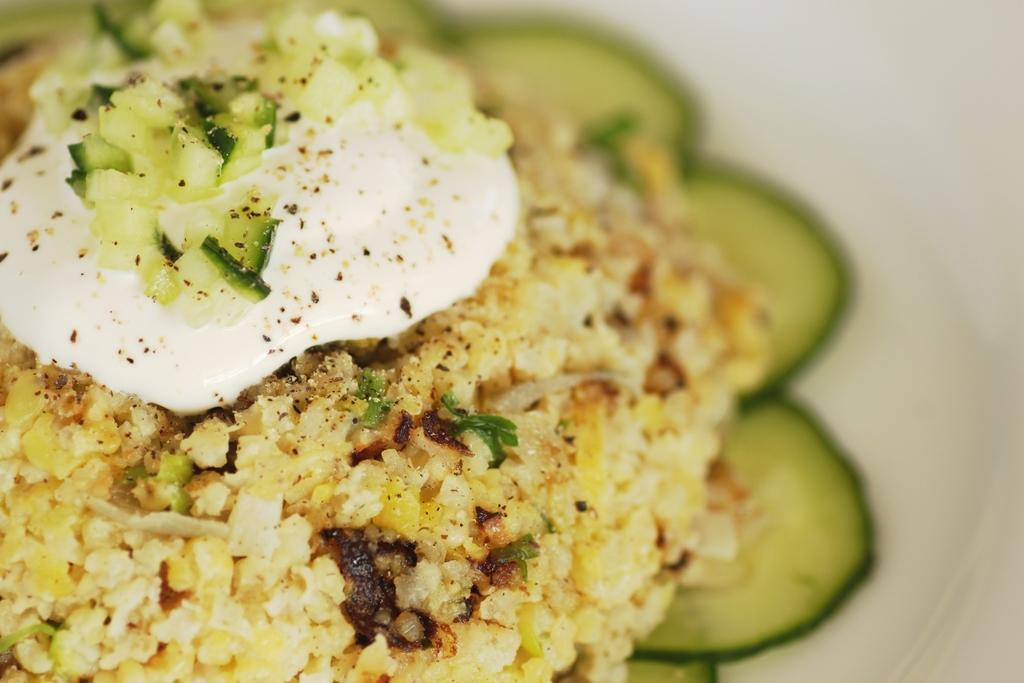What is placed on the plate in the image? There is a plate with food items on it in the image. Can you describe the food items on the plate? Unfortunately, the specific food items cannot be determined from the provided facts. Is there any utensil or accompaniment visible with the plate? The provided facts do not mention any utensils or accompaniments. How does the plate support the control system in the image? There is no control system present in the image, as it only features a plate with food items on it. 